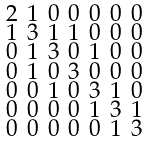Convert formula to latex. <formula><loc_0><loc_0><loc_500><loc_500>\begin{smallmatrix} 2 & 1 & 0 & 0 & 0 & 0 & 0 \\ 1 & 3 & 1 & 1 & 0 & 0 & 0 \\ 0 & 1 & 3 & 0 & 1 & 0 & 0 \\ 0 & 1 & 0 & 3 & 0 & 0 & 0 \\ 0 & 0 & 1 & 0 & 3 & 1 & 0 \\ 0 & 0 & 0 & 0 & 1 & 3 & 1 \\ 0 & 0 & 0 & 0 & 0 & 1 & 3 \end{smallmatrix}</formula> 